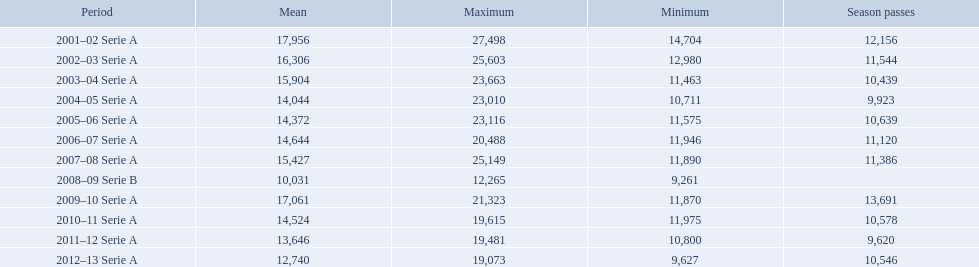What are the seasons? 2001–02 Serie A, 2002–03 Serie A, 2003–04 Serie A, 2004–05 Serie A, 2005–06 Serie A, 2006–07 Serie A, 2007–08 Serie A, 2008–09 Serie B, 2009–10 Serie A, 2010–11 Serie A, 2011–12 Serie A, 2012–13 Serie A. Which season is in 2007? 2007–08 Serie A. How many season tickets were sold that season? 11,386. 